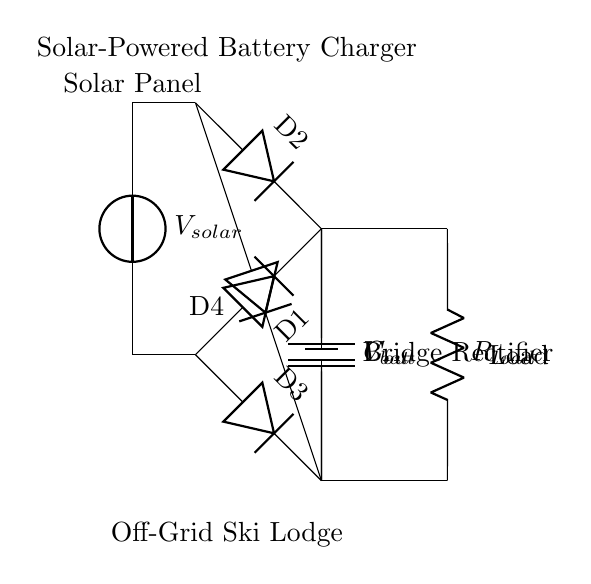What is the function of the solar panel in this circuit? The solar panel generates electrical energy from sunlight, represented as a voltage source labeled V_solar in the diagram.
Answer: Generate electrical energy How many diodes are used in the bridge rectifier? The diagram clearly shows four diodes labeled D1, D2, D3, and D4 connected in a bridge configuration.
Answer: Four diodes What is the purpose of the output capacitor, C_out? The output capacitor smooths the rectified output voltage by reducing ripple, maintaining a more constant voltage supply to the battery and load.
Answer: Smooth voltage What is the load connected to the battery in this circuit? The load is represented as a resistor labeled R_load, which consumes power from the battery. It is directly connected in parallel to the output terminals of the bridge rectifier.
Answer: Resistor Which component controls the flow of current to the battery? The battery, represented as V_bat in the circuit, is the component that stores energy and its internal structure allows it to accept the current produced by the bridge rectifier.
Answer: Battery In a bridge rectifier, what condition must the diodes meet during operation? The diodes must be forward-biased alternately to allow current flow in both halves of the input waveform, ensuring a continuous output.
Answer: Forward-biased What is the significance of using a bridge rectifier compared to a single diode rectifier? A bridge rectifier allows both halves of the AC waveform to contribute to the output, providing a higher average output voltage and better efficiency, in contrast to a single diode that uses only half the waveform.
Answer: Higher efficiency 